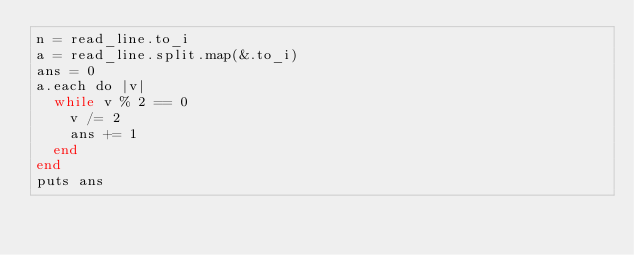<code> <loc_0><loc_0><loc_500><loc_500><_Crystal_>n = read_line.to_i
a = read_line.split.map(&.to_i)
ans = 0
a.each do |v|
  while v % 2 == 0
    v /= 2
    ans += 1
  end
end
puts ans
</code> 